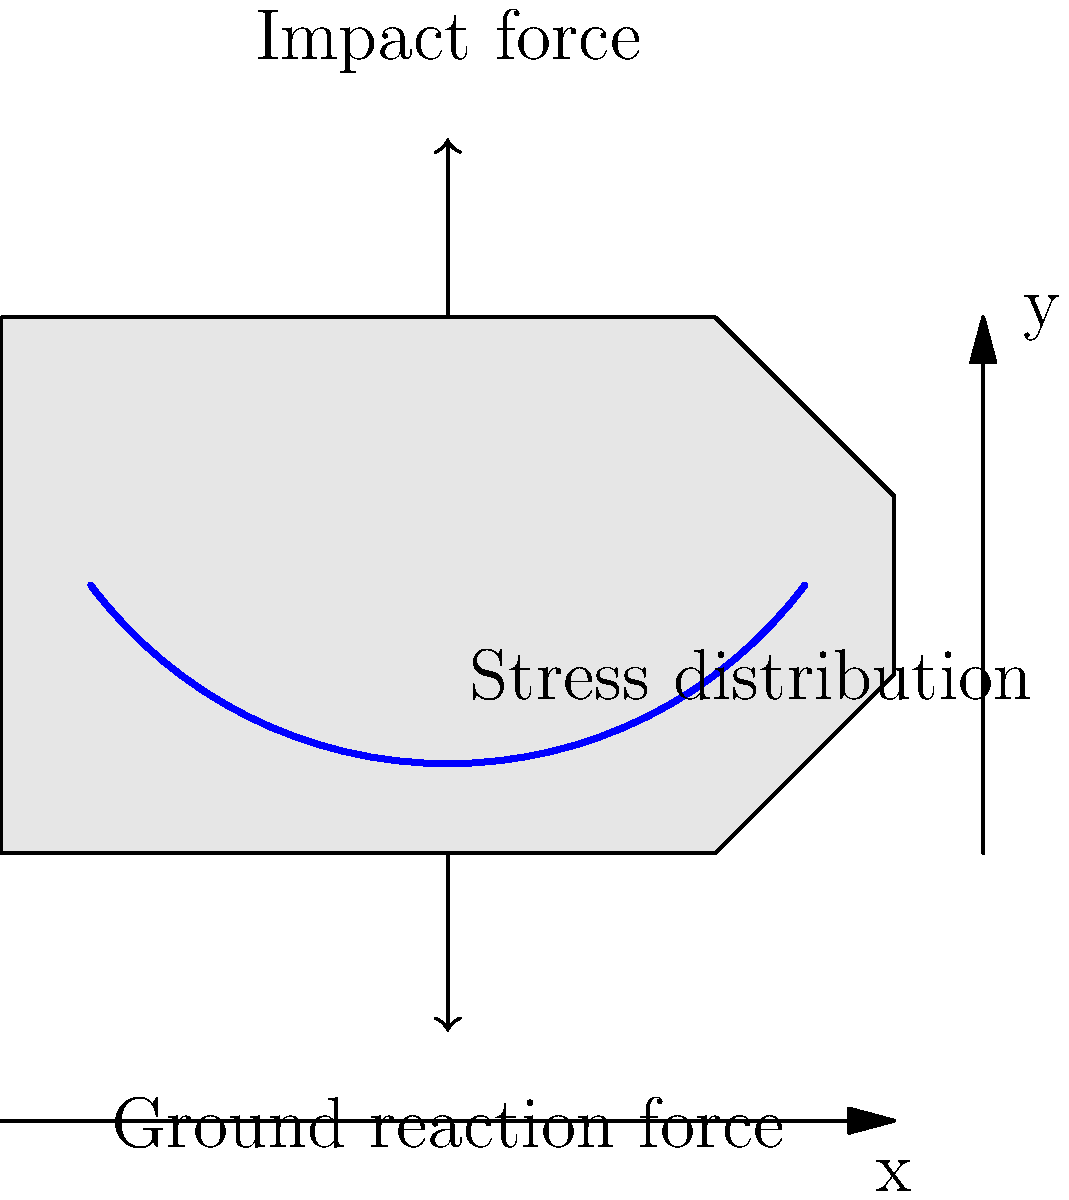During a defensive tackle in soccer, a player's cleat experiences both ground reaction force and impact force. The diagram shows a simplified stress distribution curve in the cleat. If the maximum stress occurs at point A (x = 50 mm, y = 10 mm), and the stress at the heel (x = 0, y = 30 mm) is 40% of the maximum stress, what is the approximate stress at the toe (x = 100 mm, y = 30 mm) as a percentage of the maximum stress? To solve this problem, we'll follow these steps:

1) First, let's understand the stress distribution curve. It's roughly parabolic, with the maximum stress at point A (50 mm, 10 mm).

2) We're given that the stress at the heel (0 mm, 30 mm) is 40% of the maximum stress.

3) Due to the symmetry of the parabolic curve and the cleat shape, we can assume that the stress distribution is approximately symmetric around the point of maximum stress.

4) The distance from the heel to point A is:
   $$\sqrt{(50-0)^2 + (10-30)^2} = \sqrt{2500 + 400} = \sqrt{2900} \approx 53.9\text{ mm}$$

5) The distance from point A to the toe is:
   $$\sqrt{(100-50)^2 + (30-10)^2} = \sqrt{2500 + 400} = \sqrt{2900} \approx 53.9\text{ mm}$$

6) Since these distances are equal and the curve is approximately symmetric, we can infer that the stress at the toe should be about the same as the stress at the heel.

7) Therefore, the stress at the toe should also be approximately 40% of the maximum stress.
Answer: 40% 